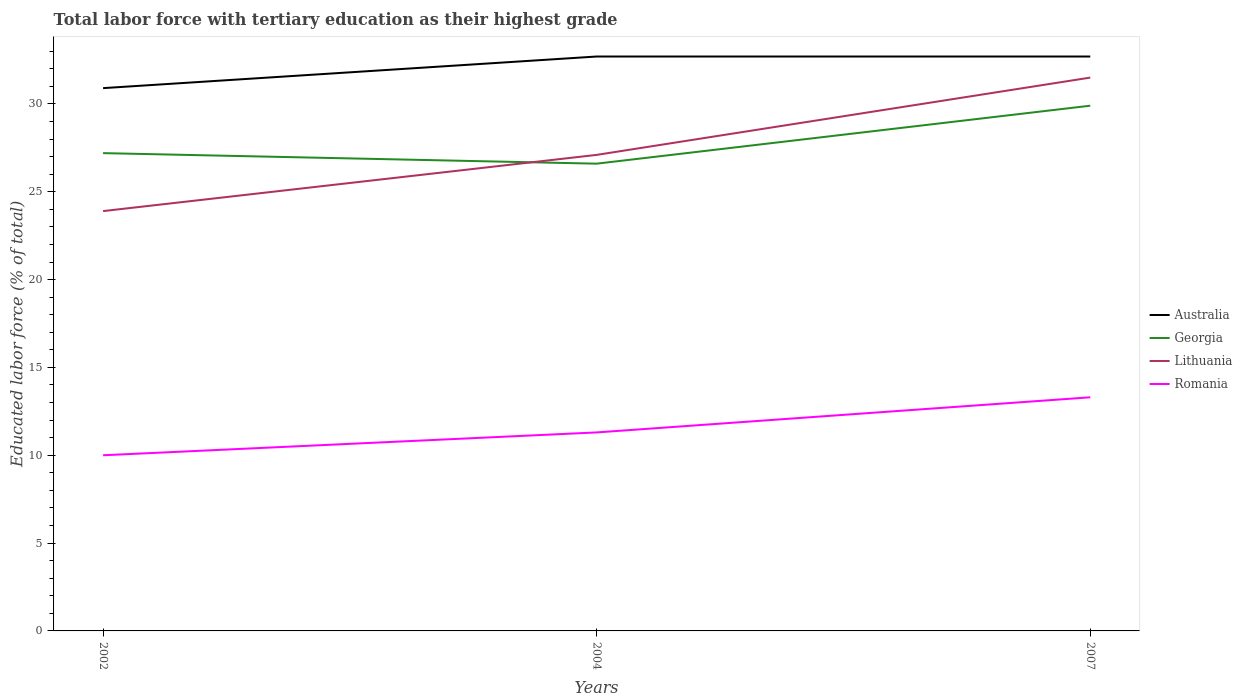Across all years, what is the maximum percentage of male labor force with tertiary education in Australia?
Provide a succinct answer. 30.9. In which year was the percentage of male labor force with tertiary education in Georgia maximum?
Provide a succinct answer. 2004. What is the difference between the highest and the second highest percentage of male labor force with tertiary education in Australia?
Ensure brevity in your answer.  1.8. Is the percentage of male labor force with tertiary education in Lithuania strictly greater than the percentage of male labor force with tertiary education in Romania over the years?
Provide a succinct answer. No. What is the difference between two consecutive major ticks on the Y-axis?
Make the answer very short. 5. Does the graph contain any zero values?
Your response must be concise. No. Does the graph contain grids?
Your response must be concise. No. What is the title of the graph?
Ensure brevity in your answer.  Total labor force with tertiary education as their highest grade. Does "Mexico" appear as one of the legend labels in the graph?
Provide a succinct answer. No. What is the label or title of the X-axis?
Make the answer very short. Years. What is the label or title of the Y-axis?
Keep it short and to the point. Educated labor force (% of total). What is the Educated labor force (% of total) of Australia in 2002?
Provide a short and direct response. 30.9. What is the Educated labor force (% of total) in Georgia in 2002?
Your answer should be very brief. 27.2. What is the Educated labor force (% of total) of Lithuania in 2002?
Provide a succinct answer. 23.9. What is the Educated labor force (% of total) in Romania in 2002?
Give a very brief answer. 10. What is the Educated labor force (% of total) in Australia in 2004?
Your answer should be compact. 32.7. What is the Educated labor force (% of total) of Georgia in 2004?
Give a very brief answer. 26.6. What is the Educated labor force (% of total) in Lithuania in 2004?
Keep it short and to the point. 27.1. What is the Educated labor force (% of total) of Romania in 2004?
Offer a terse response. 11.3. What is the Educated labor force (% of total) in Australia in 2007?
Offer a terse response. 32.7. What is the Educated labor force (% of total) in Georgia in 2007?
Offer a very short reply. 29.9. What is the Educated labor force (% of total) of Lithuania in 2007?
Provide a succinct answer. 31.5. What is the Educated labor force (% of total) of Romania in 2007?
Keep it short and to the point. 13.3. Across all years, what is the maximum Educated labor force (% of total) in Australia?
Make the answer very short. 32.7. Across all years, what is the maximum Educated labor force (% of total) of Georgia?
Your response must be concise. 29.9. Across all years, what is the maximum Educated labor force (% of total) in Lithuania?
Provide a short and direct response. 31.5. Across all years, what is the maximum Educated labor force (% of total) in Romania?
Offer a terse response. 13.3. Across all years, what is the minimum Educated labor force (% of total) in Australia?
Provide a short and direct response. 30.9. Across all years, what is the minimum Educated labor force (% of total) in Georgia?
Your answer should be compact. 26.6. Across all years, what is the minimum Educated labor force (% of total) in Lithuania?
Provide a succinct answer. 23.9. What is the total Educated labor force (% of total) of Australia in the graph?
Offer a terse response. 96.3. What is the total Educated labor force (% of total) of Georgia in the graph?
Offer a terse response. 83.7. What is the total Educated labor force (% of total) in Lithuania in the graph?
Offer a very short reply. 82.5. What is the total Educated labor force (% of total) of Romania in the graph?
Make the answer very short. 34.6. What is the difference between the Educated labor force (% of total) in Romania in 2002 and that in 2004?
Provide a succinct answer. -1.3. What is the difference between the Educated labor force (% of total) in Georgia in 2002 and that in 2007?
Your answer should be very brief. -2.7. What is the difference between the Educated labor force (% of total) in Australia in 2004 and that in 2007?
Keep it short and to the point. 0. What is the difference between the Educated labor force (% of total) in Australia in 2002 and the Educated labor force (% of total) in Georgia in 2004?
Your answer should be compact. 4.3. What is the difference between the Educated labor force (% of total) in Australia in 2002 and the Educated labor force (% of total) in Romania in 2004?
Offer a very short reply. 19.6. What is the difference between the Educated labor force (% of total) of Georgia in 2002 and the Educated labor force (% of total) of Lithuania in 2004?
Provide a short and direct response. 0.1. What is the difference between the Educated labor force (% of total) of Australia in 2002 and the Educated labor force (% of total) of Romania in 2007?
Your response must be concise. 17.6. What is the difference between the Educated labor force (% of total) of Georgia in 2002 and the Educated labor force (% of total) of Lithuania in 2007?
Ensure brevity in your answer.  -4.3. What is the difference between the Educated labor force (% of total) in Georgia in 2002 and the Educated labor force (% of total) in Romania in 2007?
Make the answer very short. 13.9. What is the difference between the Educated labor force (% of total) of Lithuania in 2002 and the Educated labor force (% of total) of Romania in 2007?
Your response must be concise. 10.6. What is the difference between the Educated labor force (% of total) of Australia in 2004 and the Educated labor force (% of total) of Lithuania in 2007?
Give a very brief answer. 1.2. What is the average Educated labor force (% of total) of Australia per year?
Offer a very short reply. 32.1. What is the average Educated labor force (% of total) of Georgia per year?
Ensure brevity in your answer.  27.9. What is the average Educated labor force (% of total) in Lithuania per year?
Your response must be concise. 27.5. What is the average Educated labor force (% of total) of Romania per year?
Give a very brief answer. 11.53. In the year 2002, what is the difference between the Educated labor force (% of total) in Australia and Educated labor force (% of total) in Romania?
Provide a succinct answer. 20.9. In the year 2002, what is the difference between the Educated labor force (% of total) in Georgia and Educated labor force (% of total) in Lithuania?
Give a very brief answer. 3.3. In the year 2002, what is the difference between the Educated labor force (% of total) of Georgia and Educated labor force (% of total) of Romania?
Your answer should be compact. 17.2. In the year 2004, what is the difference between the Educated labor force (% of total) in Australia and Educated labor force (% of total) in Romania?
Offer a terse response. 21.4. In the year 2004, what is the difference between the Educated labor force (% of total) in Georgia and Educated labor force (% of total) in Lithuania?
Your response must be concise. -0.5. In the year 2004, what is the difference between the Educated labor force (% of total) in Georgia and Educated labor force (% of total) in Romania?
Offer a very short reply. 15.3. In the year 2007, what is the difference between the Educated labor force (% of total) of Australia and Educated labor force (% of total) of Georgia?
Make the answer very short. 2.8. In the year 2007, what is the difference between the Educated labor force (% of total) of Australia and Educated labor force (% of total) of Lithuania?
Your answer should be compact. 1.2. In the year 2007, what is the difference between the Educated labor force (% of total) in Australia and Educated labor force (% of total) in Romania?
Give a very brief answer. 19.4. In the year 2007, what is the difference between the Educated labor force (% of total) of Georgia and Educated labor force (% of total) of Lithuania?
Your answer should be very brief. -1.6. What is the ratio of the Educated labor force (% of total) in Australia in 2002 to that in 2004?
Give a very brief answer. 0.94. What is the ratio of the Educated labor force (% of total) of Georgia in 2002 to that in 2004?
Your response must be concise. 1.02. What is the ratio of the Educated labor force (% of total) in Lithuania in 2002 to that in 2004?
Your answer should be compact. 0.88. What is the ratio of the Educated labor force (% of total) of Romania in 2002 to that in 2004?
Provide a short and direct response. 0.89. What is the ratio of the Educated labor force (% of total) in Australia in 2002 to that in 2007?
Offer a very short reply. 0.94. What is the ratio of the Educated labor force (% of total) in Georgia in 2002 to that in 2007?
Provide a short and direct response. 0.91. What is the ratio of the Educated labor force (% of total) of Lithuania in 2002 to that in 2007?
Your response must be concise. 0.76. What is the ratio of the Educated labor force (% of total) of Romania in 2002 to that in 2007?
Your answer should be compact. 0.75. What is the ratio of the Educated labor force (% of total) in Australia in 2004 to that in 2007?
Give a very brief answer. 1. What is the ratio of the Educated labor force (% of total) in Georgia in 2004 to that in 2007?
Provide a succinct answer. 0.89. What is the ratio of the Educated labor force (% of total) of Lithuania in 2004 to that in 2007?
Make the answer very short. 0.86. What is the ratio of the Educated labor force (% of total) in Romania in 2004 to that in 2007?
Keep it short and to the point. 0.85. What is the difference between the highest and the second highest Educated labor force (% of total) of Australia?
Provide a short and direct response. 0. What is the difference between the highest and the second highest Educated labor force (% of total) in Georgia?
Your response must be concise. 2.7. What is the difference between the highest and the second highest Educated labor force (% of total) of Romania?
Ensure brevity in your answer.  2. What is the difference between the highest and the lowest Educated labor force (% of total) in Georgia?
Offer a very short reply. 3.3. What is the difference between the highest and the lowest Educated labor force (% of total) in Lithuania?
Your answer should be compact. 7.6. 